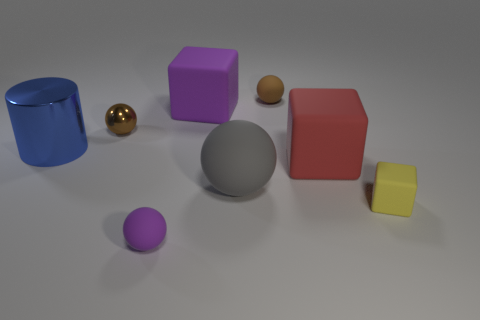Is the number of yellow things right of the gray ball greater than the number of tiny gray balls?
Give a very brief answer. Yes. How many tiny things are to the right of the purple block and behind the large blue thing?
Ensure brevity in your answer.  1. What color is the metal object in front of the brown metal object that is behind the tiny block?
Your answer should be compact. Blue. How many tiny matte objects have the same color as the metal sphere?
Provide a succinct answer. 1. Does the small metallic object have the same color as the small rubber object that is behind the large rubber sphere?
Provide a succinct answer. Yes. Are there fewer tiny purple rubber objects than big purple cylinders?
Offer a very short reply. No. Are there more tiny matte things that are in front of the tiny cube than blue shiny cylinders in front of the purple rubber sphere?
Offer a terse response. Yes. Is the red thing made of the same material as the blue cylinder?
Provide a short and direct response. No. What number of tiny rubber things are in front of the small brown thing to the left of the brown rubber thing?
Keep it short and to the point. 2. There is a small matte ball behind the tiny matte block; does it have the same color as the shiny sphere?
Give a very brief answer. Yes. 